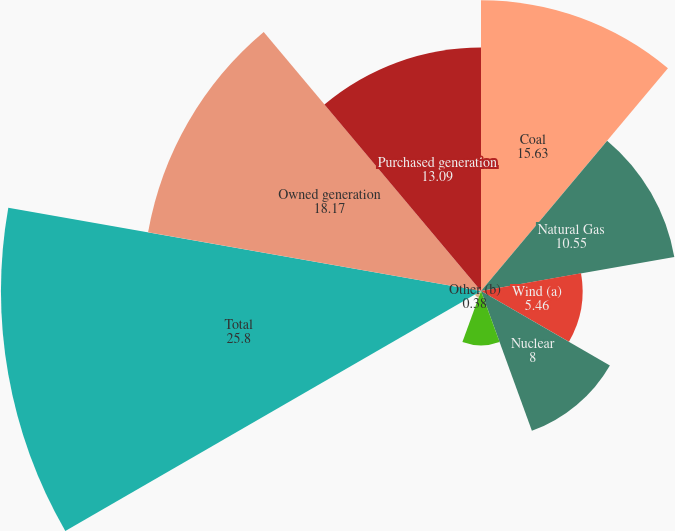Convert chart. <chart><loc_0><loc_0><loc_500><loc_500><pie_chart><fcel>Coal<fcel>Natural Gas<fcel>Wind (a)<fcel>Nuclear<fcel>Hydroelectric<fcel>Other (b)<fcel>Total<fcel>Owned generation<fcel>Purchased generation<nl><fcel>15.63%<fcel>10.55%<fcel>5.46%<fcel>8.0%<fcel>2.92%<fcel>0.38%<fcel>25.8%<fcel>18.17%<fcel>13.09%<nl></chart> 